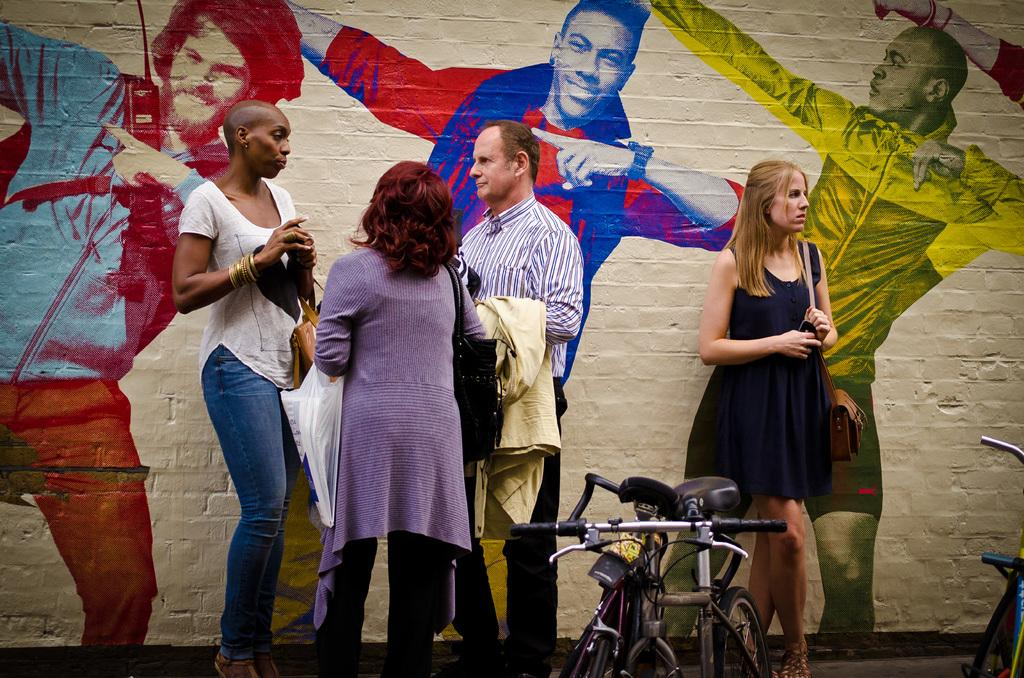What can be seen in the foreground of the picture? There are people and bicycles in the foreground of the picture. What is located in the background of the picture? There is a wall in the background of the picture. What is depicted on the wall? The wall is painted with human figures. What is the tax rate for the bicycles in the people are riding in the image? There is no information about tax rates in the image, as it focuses on the people and bicycles in the foreground and the painted wall in the background. 